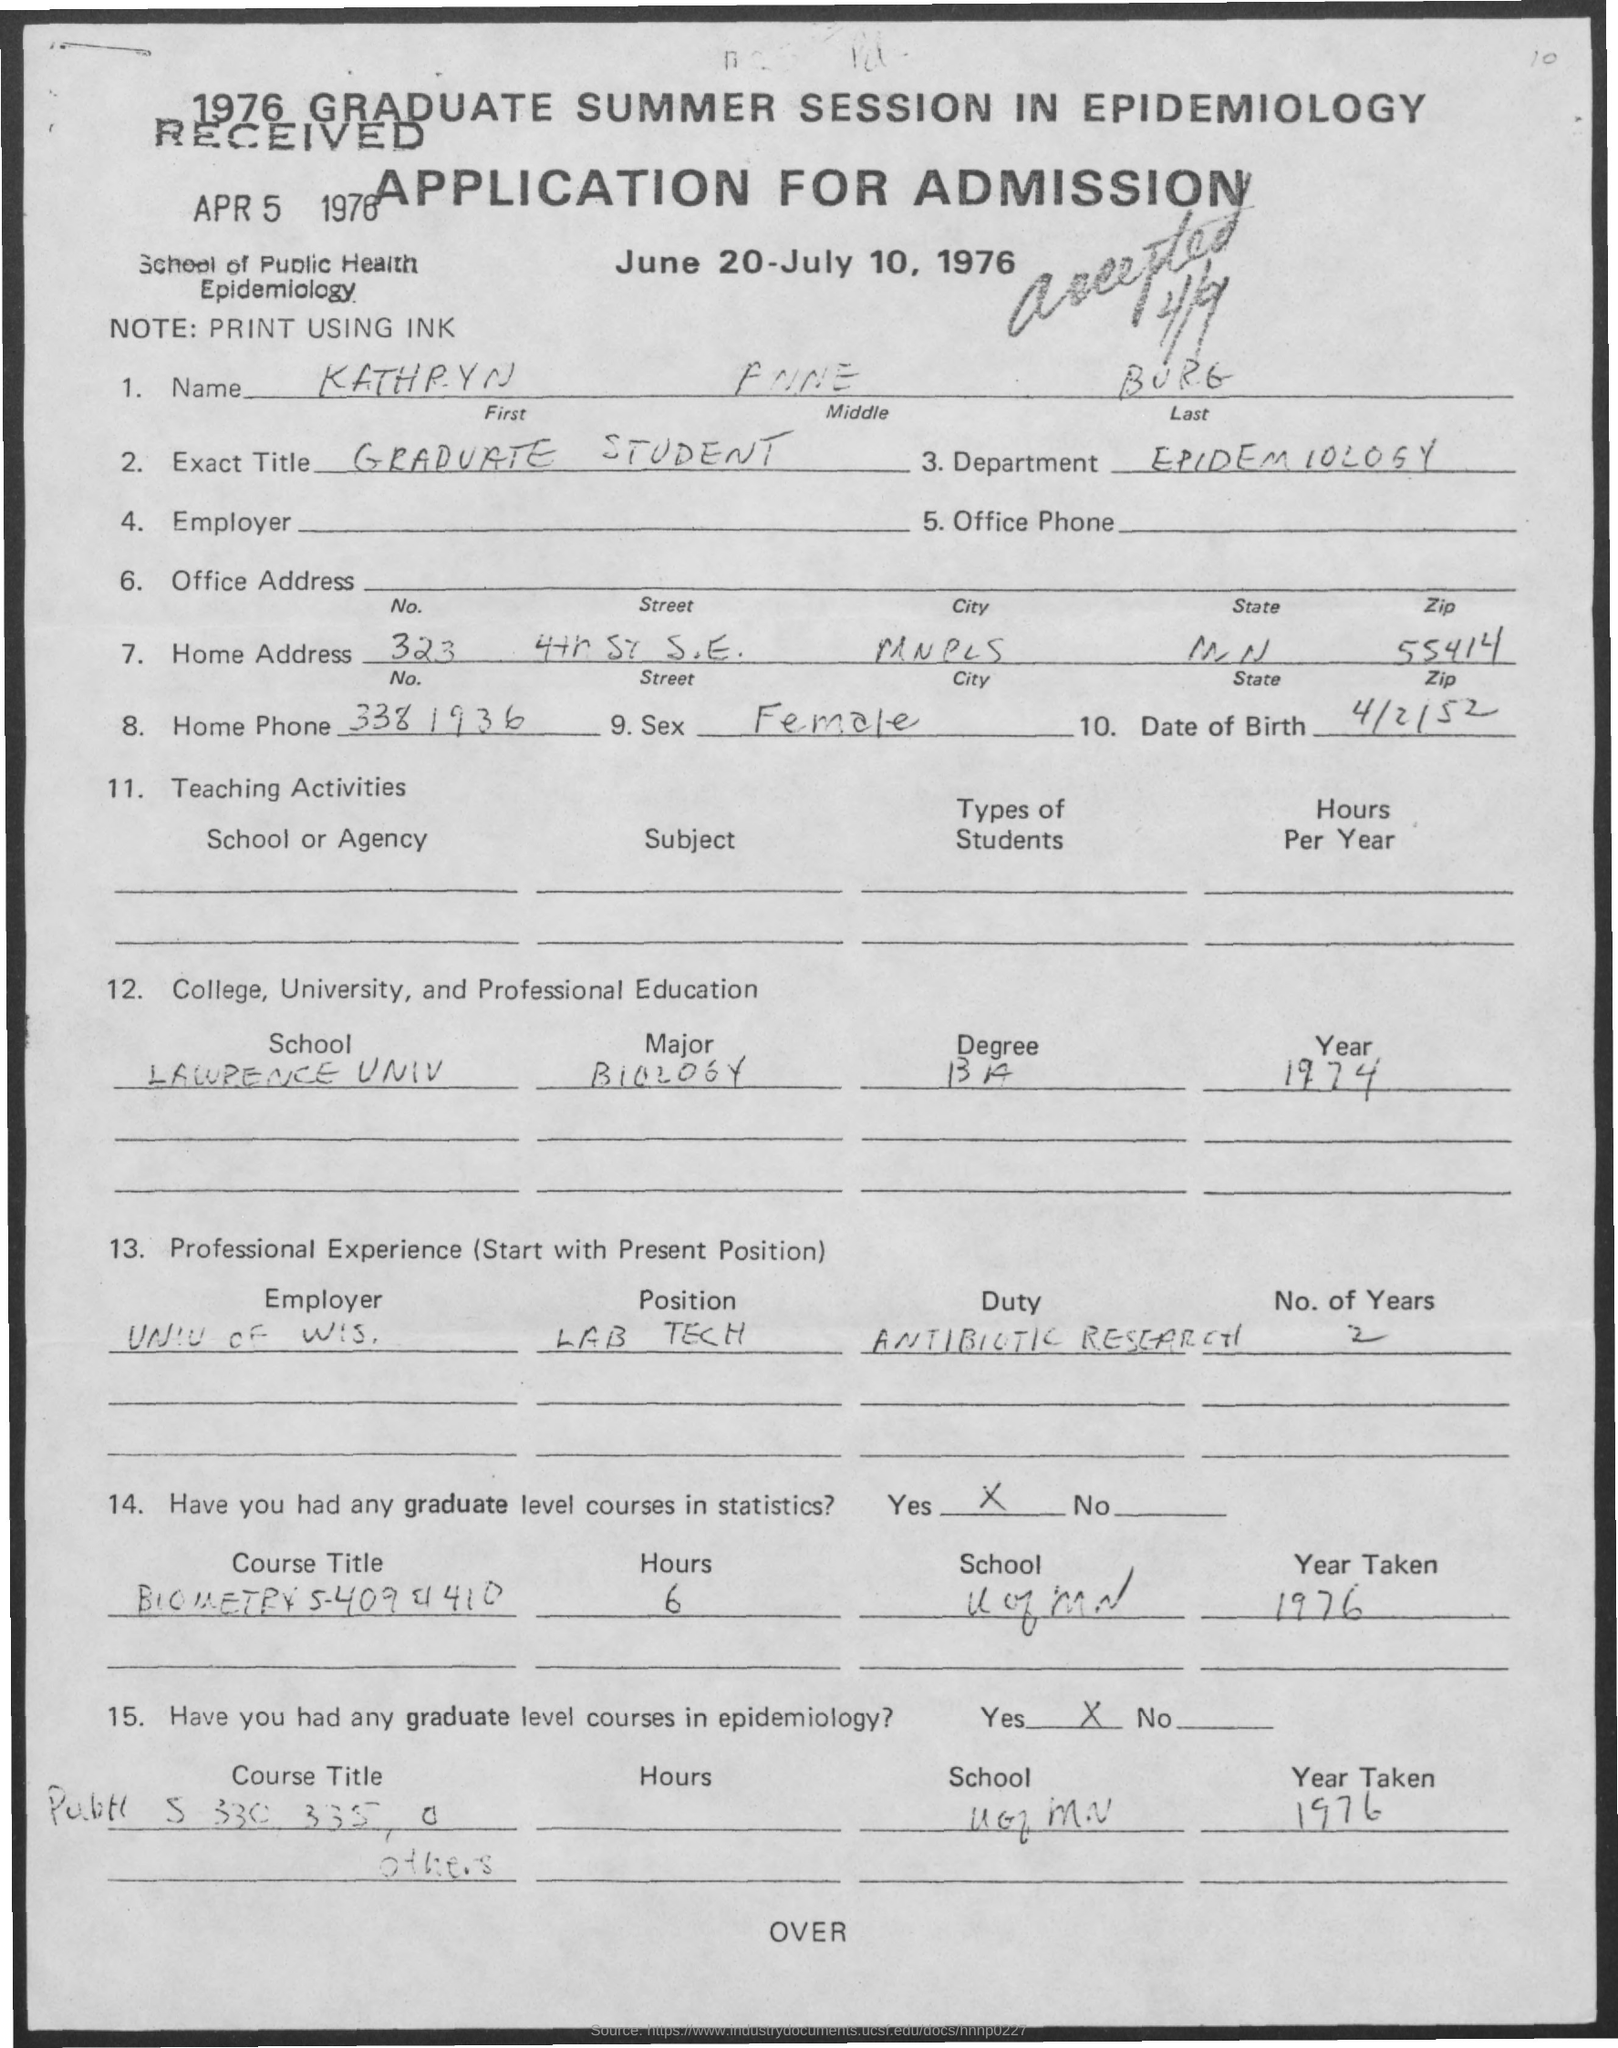What is written in the Exact Title Field ?
Give a very brief answer. GRADUATE STUDENT. What is the Zip code for Home Address?
Keep it short and to the point. 55414. What is the Department Name  ?
Provide a short and direct response. EPIDEMIOLOGY. What is the Date of Birth ?
Ensure brevity in your answer.  4/2/52. What is the Home Address Number ?
Your response must be concise. 323. What is written in the Sex Field ?
Keep it short and to the point. Female. 